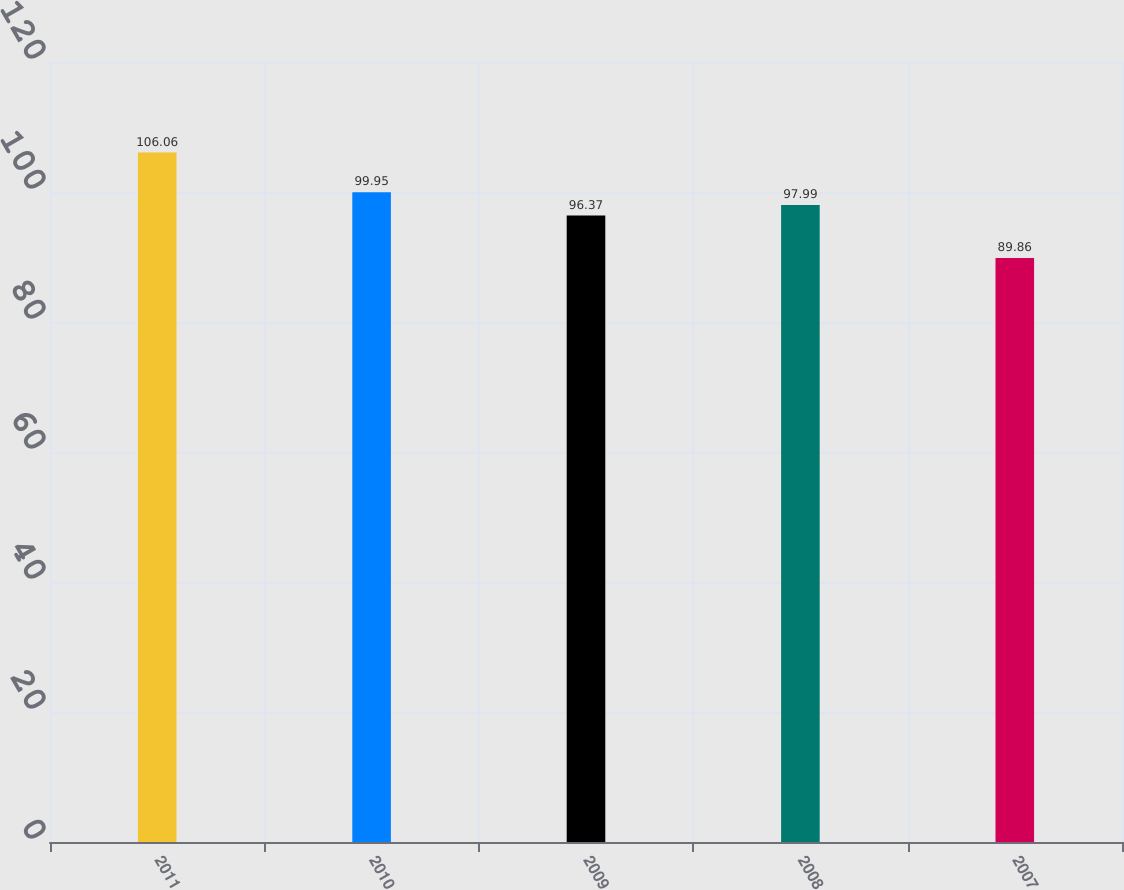Convert chart. <chart><loc_0><loc_0><loc_500><loc_500><bar_chart><fcel>2011<fcel>2010<fcel>2009<fcel>2008<fcel>2007<nl><fcel>106.06<fcel>99.95<fcel>96.37<fcel>97.99<fcel>89.86<nl></chart> 